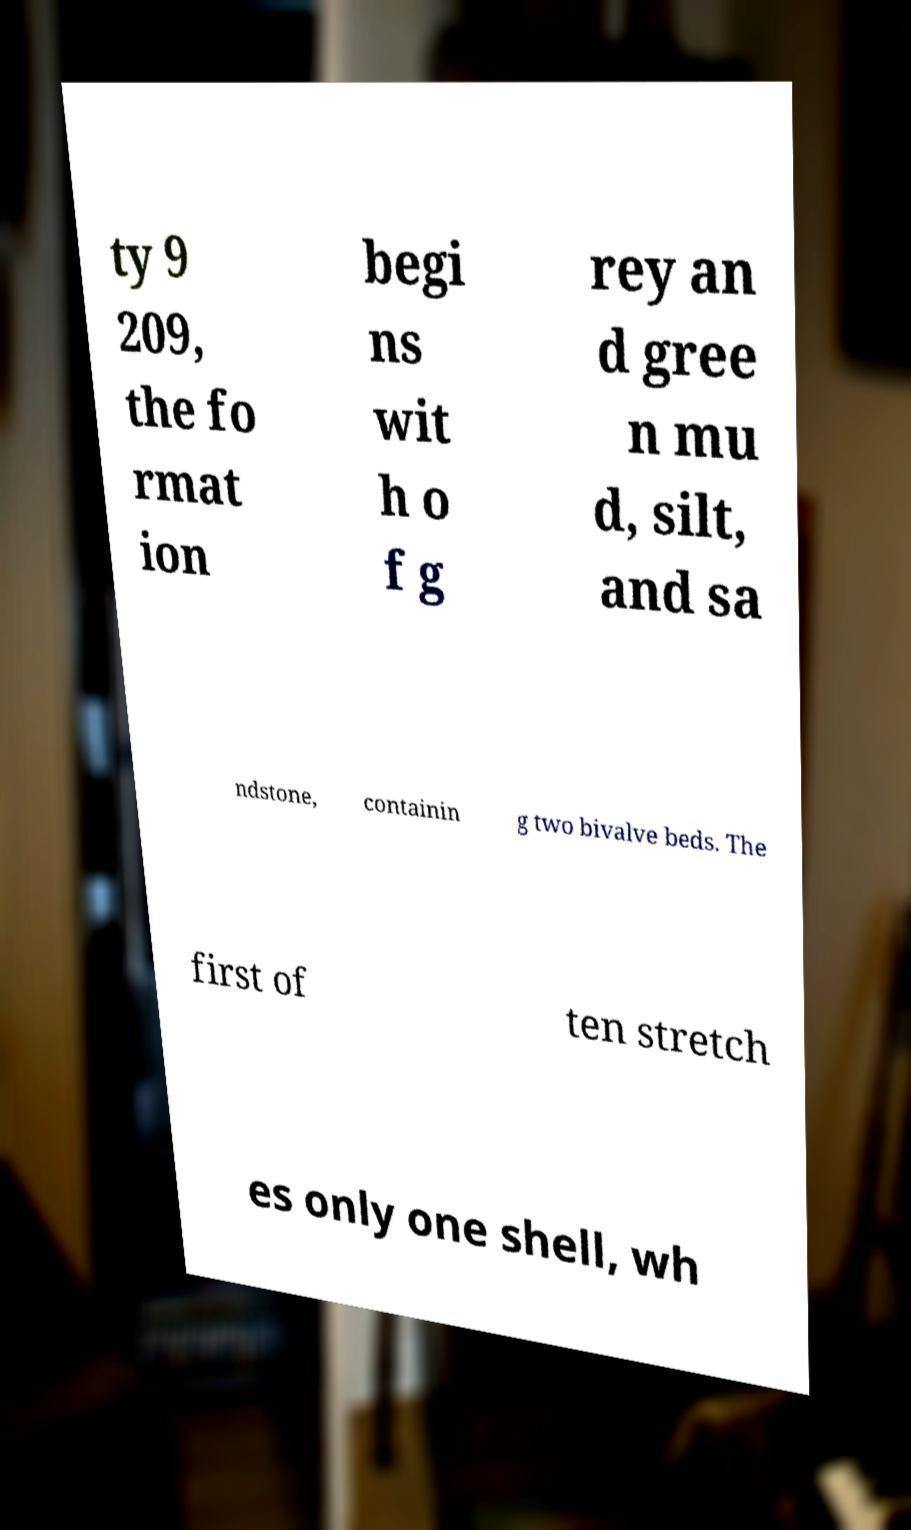There's text embedded in this image that I need extracted. Can you transcribe it verbatim? ty 9 209, the fo rmat ion begi ns wit h o f g rey an d gree n mu d, silt, and sa ndstone, containin g two bivalve beds. The first of ten stretch es only one shell, wh 